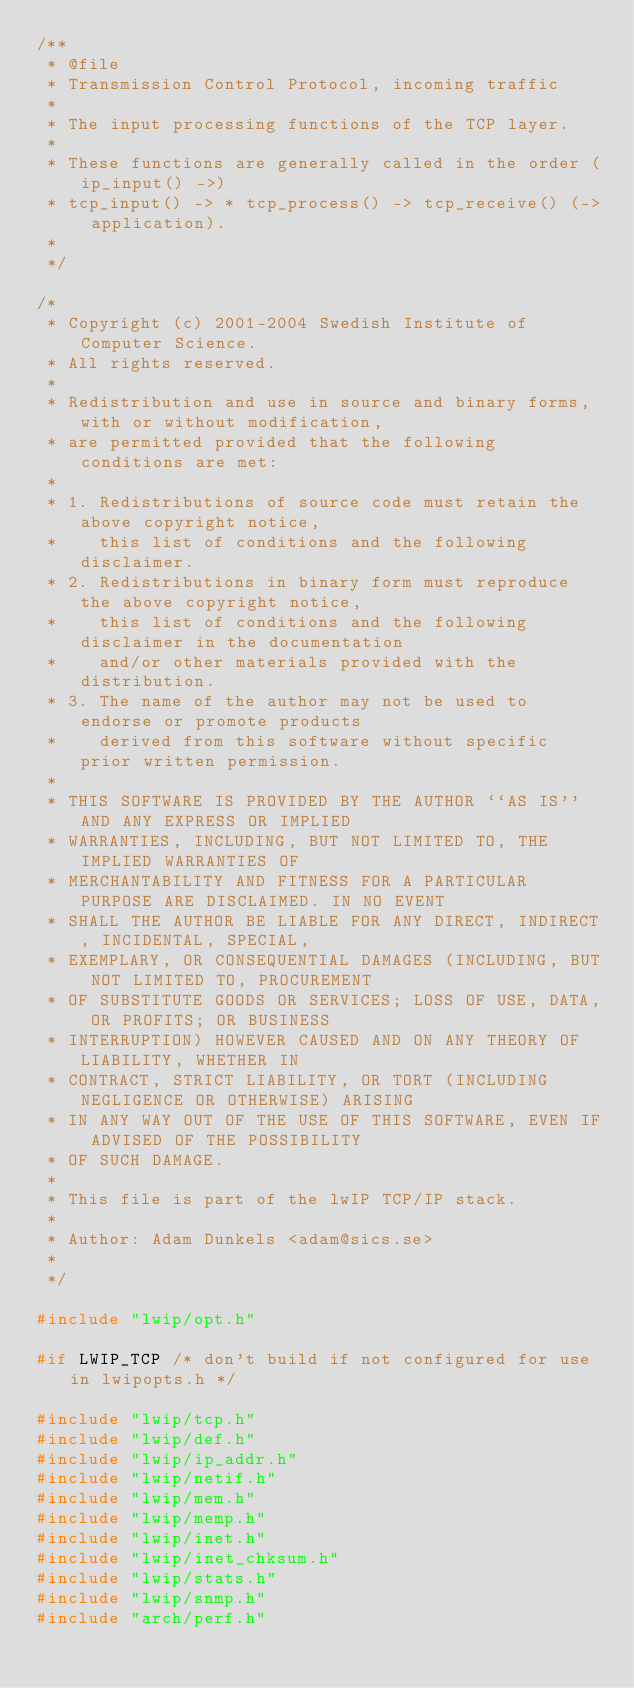<code> <loc_0><loc_0><loc_500><loc_500><_C_>/**
 * @file
 * Transmission Control Protocol, incoming traffic
 *
 * The input processing functions of the TCP layer.
 *
 * These functions are generally called in the order (ip_input() ->)
 * tcp_input() -> * tcp_process() -> tcp_receive() (-> application).
 * 
 */

/*
 * Copyright (c) 2001-2004 Swedish Institute of Computer Science.
 * All rights reserved.
 *
 * Redistribution and use in source and binary forms, with or without modification,
 * are permitted provided that the following conditions are met:
 *
 * 1. Redistributions of source code must retain the above copyright notice,
 *    this list of conditions and the following disclaimer.
 * 2. Redistributions in binary form must reproduce the above copyright notice,
 *    this list of conditions and the following disclaimer in the documentation
 *    and/or other materials provided with the distribution.
 * 3. The name of the author may not be used to endorse or promote products
 *    derived from this software without specific prior written permission.
 *
 * THIS SOFTWARE IS PROVIDED BY THE AUTHOR ``AS IS'' AND ANY EXPRESS OR IMPLIED
 * WARRANTIES, INCLUDING, BUT NOT LIMITED TO, THE IMPLIED WARRANTIES OF
 * MERCHANTABILITY AND FITNESS FOR A PARTICULAR PURPOSE ARE DISCLAIMED. IN NO EVENT
 * SHALL THE AUTHOR BE LIABLE FOR ANY DIRECT, INDIRECT, INCIDENTAL, SPECIAL,
 * EXEMPLARY, OR CONSEQUENTIAL DAMAGES (INCLUDING, BUT NOT LIMITED TO, PROCUREMENT
 * OF SUBSTITUTE GOODS OR SERVICES; LOSS OF USE, DATA, OR PROFITS; OR BUSINESS
 * INTERRUPTION) HOWEVER CAUSED AND ON ANY THEORY OF LIABILITY, WHETHER IN
 * CONTRACT, STRICT LIABILITY, OR TORT (INCLUDING NEGLIGENCE OR OTHERWISE) ARISING
 * IN ANY WAY OUT OF THE USE OF THIS SOFTWARE, EVEN IF ADVISED OF THE POSSIBILITY
 * OF SUCH DAMAGE.
 *
 * This file is part of the lwIP TCP/IP stack.
 *
 * Author: Adam Dunkels <adam@sics.se>
 *
 */

#include "lwip/opt.h"

#if LWIP_TCP /* don't build if not configured for use in lwipopts.h */

#include "lwip/tcp.h"
#include "lwip/def.h"
#include "lwip/ip_addr.h"
#include "lwip/netif.h"
#include "lwip/mem.h"
#include "lwip/memp.h"
#include "lwip/inet.h"
#include "lwip/inet_chksum.h"
#include "lwip/stats.h"
#include "lwip/snmp.h"
#include "arch/perf.h"
</code> 